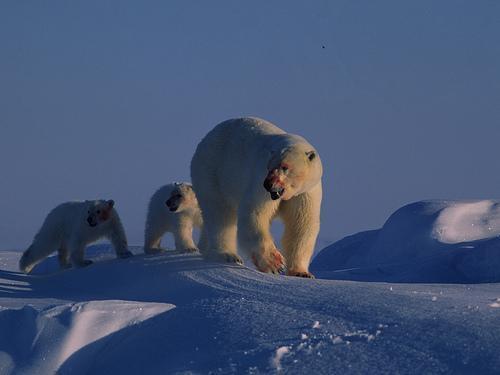How many bears?
Give a very brief answer. 3. 